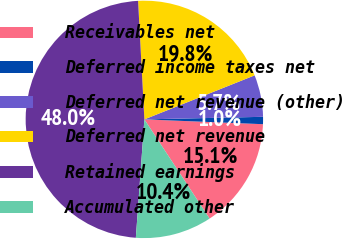<chart> <loc_0><loc_0><loc_500><loc_500><pie_chart><fcel>Receivables net<fcel>Deferred income taxes net<fcel>Deferred net revenue (other)<fcel>Deferred net revenue<fcel>Retained earnings<fcel>Accumulated other<nl><fcel>15.1%<fcel>0.99%<fcel>5.7%<fcel>19.8%<fcel>48.01%<fcel>10.4%<nl></chart> 